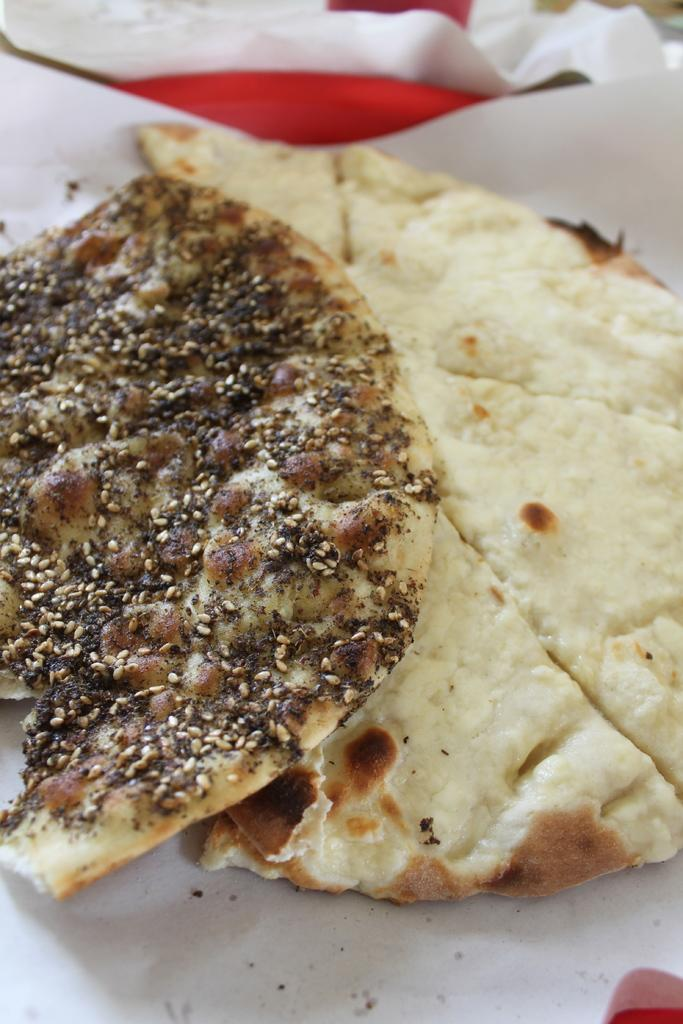What type of food can be seen in the image? There are two white-colored rotis in the image. What is on one of the rotis? Ingredients are visible on one of the rotis. What is located under the rotis? There is a white-colored thing under the rotis. How many flies can be seen on the rotis in the image? There are no flies visible on the rotis in the image. What type of honey is drizzled on the rotis in the image? There is no honey present on the rotis in the image. 